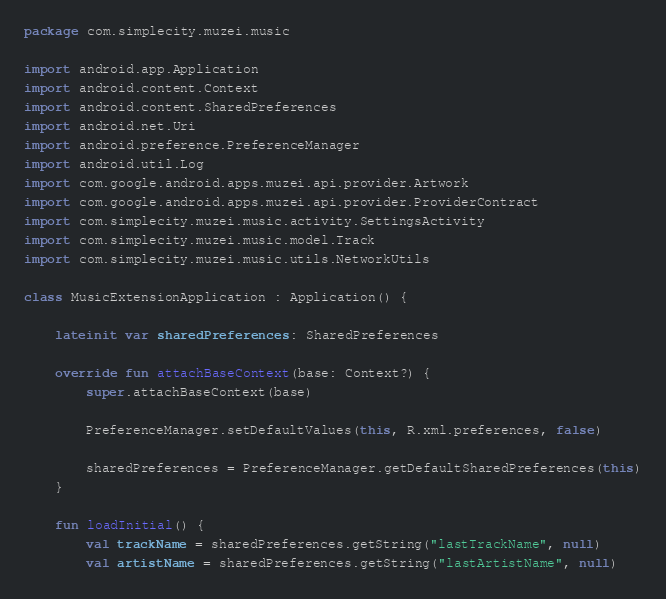Convert code to text. <code><loc_0><loc_0><loc_500><loc_500><_Kotlin_>package com.simplecity.muzei.music

import android.app.Application
import android.content.Context
import android.content.SharedPreferences
import android.net.Uri
import android.preference.PreferenceManager
import android.util.Log
import com.google.android.apps.muzei.api.provider.Artwork
import com.google.android.apps.muzei.api.provider.ProviderContract
import com.simplecity.muzei.music.activity.SettingsActivity
import com.simplecity.muzei.music.model.Track
import com.simplecity.muzei.music.utils.NetworkUtils

class MusicExtensionApplication : Application() {

    lateinit var sharedPreferences: SharedPreferences

    override fun attachBaseContext(base: Context?) {
        super.attachBaseContext(base)

        PreferenceManager.setDefaultValues(this, R.xml.preferences, false)

        sharedPreferences = PreferenceManager.getDefaultSharedPreferences(this)
    }

    fun loadInitial() {
        val trackName = sharedPreferences.getString("lastTrackName", null)
        val artistName = sharedPreferences.getString("lastArtistName", null)</code> 